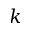<formula> <loc_0><loc_0><loc_500><loc_500>k</formula> 